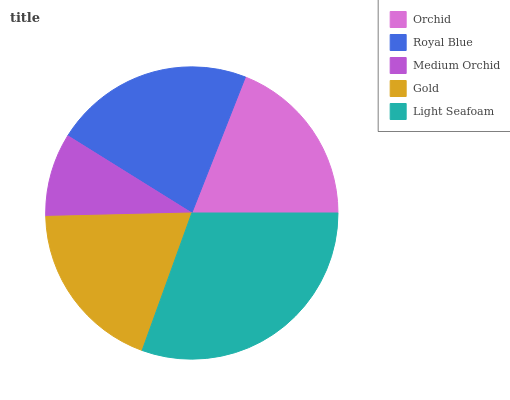Is Medium Orchid the minimum?
Answer yes or no. Yes. Is Light Seafoam the maximum?
Answer yes or no. Yes. Is Royal Blue the minimum?
Answer yes or no. No. Is Royal Blue the maximum?
Answer yes or no. No. Is Royal Blue greater than Orchid?
Answer yes or no. Yes. Is Orchid less than Royal Blue?
Answer yes or no. Yes. Is Orchid greater than Royal Blue?
Answer yes or no. No. Is Royal Blue less than Orchid?
Answer yes or no. No. Is Gold the high median?
Answer yes or no. Yes. Is Gold the low median?
Answer yes or no. Yes. Is Light Seafoam the high median?
Answer yes or no. No. Is Light Seafoam the low median?
Answer yes or no. No. 